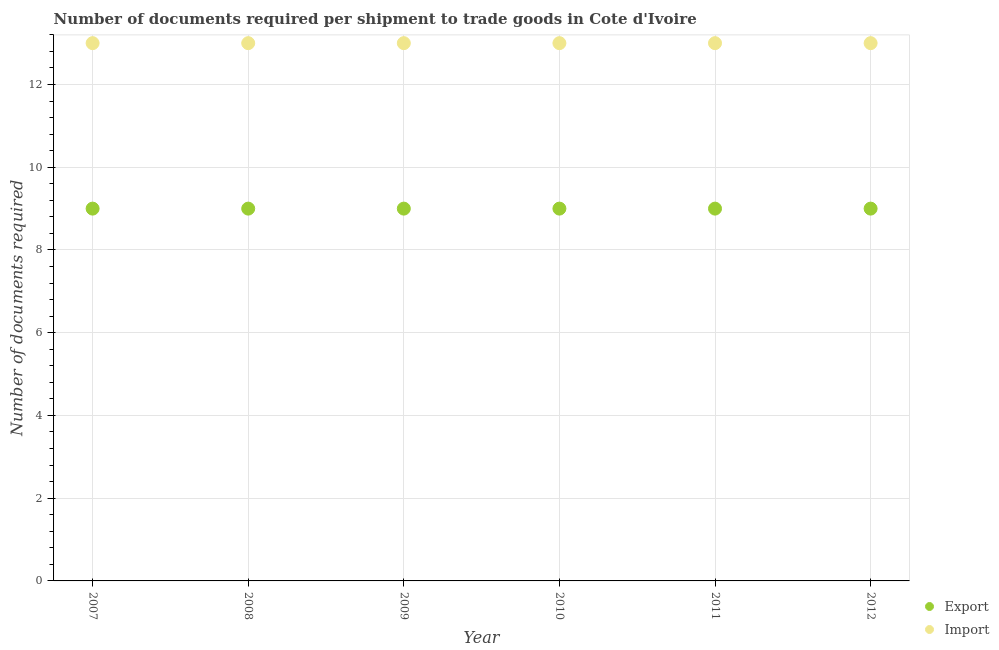What is the number of documents required to export goods in 2012?
Offer a terse response. 9. Across all years, what is the maximum number of documents required to export goods?
Offer a terse response. 9. Across all years, what is the minimum number of documents required to import goods?
Keep it short and to the point. 13. In which year was the number of documents required to import goods minimum?
Your answer should be very brief. 2007. What is the total number of documents required to import goods in the graph?
Offer a very short reply. 78. What is the difference between the number of documents required to import goods in 2011 and the number of documents required to export goods in 2010?
Ensure brevity in your answer.  4. In the year 2011, what is the difference between the number of documents required to export goods and number of documents required to import goods?
Offer a very short reply. -4. What is the ratio of the number of documents required to export goods in 2007 to that in 2008?
Offer a very short reply. 1. What is the difference between the highest and the second highest number of documents required to export goods?
Offer a terse response. 0. Does the number of documents required to export goods monotonically increase over the years?
Offer a very short reply. No. Is the number of documents required to export goods strictly greater than the number of documents required to import goods over the years?
Your answer should be very brief. No. Is the number of documents required to import goods strictly less than the number of documents required to export goods over the years?
Give a very brief answer. No. How many years are there in the graph?
Provide a succinct answer. 6. Does the graph contain grids?
Make the answer very short. Yes. How are the legend labels stacked?
Make the answer very short. Vertical. What is the title of the graph?
Ensure brevity in your answer.  Number of documents required per shipment to trade goods in Cote d'Ivoire. What is the label or title of the X-axis?
Your response must be concise. Year. What is the label or title of the Y-axis?
Your answer should be compact. Number of documents required. What is the Number of documents required of Export in 2008?
Your answer should be very brief. 9. What is the Number of documents required in Export in 2010?
Provide a short and direct response. 9. What is the Number of documents required in Import in 2010?
Ensure brevity in your answer.  13. What is the Number of documents required of Import in 2012?
Your answer should be very brief. 13. Across all years, what is the minimum Number of documents required in Export?
Your answer should be very brief. 9. Across all years, what is the minimum Number of documents required in Import?
Your answer should be compact. 13. What is the total Number of documents required of Export in the graph?
Offer a very short reply. 54. What is the difference between the Number of documents required in Import in 2007 and that in 2010?
Ensure brevity in your answer.  0. What is the difference between the Number of documents required of Export in 2007 and that in 2011?
Provide a succinct answer. 0. What is the difference between the Number of documents required of Import in 2007 and that in 2011?
Give a very brief answer. 0. What is the difference between the Number of documents required in Export in 2007 and that in 2012?
Give a very brief answer. 0. What is the difference between the Number of documents required in Import in 2007 and that in 2012?
Give a very brief answer. 0. What is the difference between the Number of documents required of Export in 2008 and that in 2009?
Offer a terse response. 0. What is the difference between the Number of documents required of Import in 2008 and that in 2009?
Provide a short and direct response. 0. What is the difference between the Number of documents required of Export in 2008 and that in 2010?
Make the answer very short. 0. What is the difference between the Number of documents required of Import in 2008 and that in 2010?
Your response must be concise. 0. What is the difference between the Number of documents required in Export in 2008 and that in 2011?
Give a very brief answer. 0. What is the difference between the Number of documents required in Import in 2008 and that in 2011?
Your answer should be very brief. 0. What is the difference between the Number of documents required of Export in 2008 and that in 2012?
Offer a terse response. 0. What is the difference between the Number of documents required in Import in 2008 and that in 2012?
Your response must be concise. 0. What is the difference between the Number of documents required in Export in 2009 and that in 2010?
Provide a succinct answer. 0. What is the difference between the Number of documents required of Import in 2009 and that in 2011?
Keep it short and to the point. 0. What is the difference between the Number of documents required in Export in 2009 and that in 2012?
Provide a short and direct response. 0. What is the difference between the Number of documents required of Export in 2010 and that in 2011?
Give a very brief answer. 0. What is the difference between the Number of documents required of Export in 2007 and the Number of documents required of Import in 2009?
Your answer should be very brief. -4. What is the difference between the Number of documents required in Export in 2007 and the Number of documents required in Import in 2010?
Ensure brevity in your answer.  -4. What is the difference between the Number of documents required of Export in 2007 and the Number of documents required of Import in 2012?
Your answer should be compact. -4. What is the difference between the Number of documents required of Export in 2008 and the Number of documents required of Import in 2011?
Give a very brief answer. -4. What is the difference between the Number of documents required of Export in 2009 and the Number of documents required of Import in 2012?
Give a very brief answer. -4. What is the difference between the Number of documents required of Export in 2011 and the Number of documents required of Import in 2012?
Your response must be concise. -4. In the year 2007, what is the difference between the Number of documents required of Export and Number of documents required of Import?
Provide a succinct answer. -4. In the year 2009, what is the difference between the Number of documents required in Export and Number of documents required in Import?
Provide a succinct answer. -4. In the year 2010, what is the difference between the Number of documents required in Export and Number of documents required in Import?
Ensure brevity in your answer.  -4. What is the ratio of the Number of documents required in Export in 2007 to that in 2011?
Keep it short and to the point. 1. What is the ratio of the Number of documents required in Import in 2007 to that in 2011?
Your answer should be very brief. 1. What is the ratio of the Number of documents required of Import in 2007 to that in 2012?
Provide a short and direct response. 1. What is the ratio of the Number of documents required in Export in 2008 to that in 2009?
Provide a succinct answer. 1. What is the ratio of the Number of documents required in Import in 2008 to that in 2009?
Give a very brief answer. 1. What is the ratio of the Number of documents required of Export in 2008 to that in 2010?
Ensure brevity in your answer.  1. What is the ratio of the Number of documents required of Import in 2008 to that in 2010?
Keep it short and to the point. 1. What is the ratio of the Number of documents required in Export in 2008 to that in 2011?
Ensure brevity in your answer.  1. What is the ratio of the Number of documents required of Import in 2008 to that in 2011?
Offer a terse response. 1. What is the ratio of the Number of documents required of Import in 2008 to that in 2012?
Offer a terse response. 1. What is the ratio of the Number of documents required of Import in 2009 to that in 2010?
Your response must be concise. 1. What is the ratio of the Number of documents required of Export in 2009 to that in 2011?
Give a very brief answer. 1. What is the ratio of the Number of documents required in Import in 2009 to that in 2011?
Provide a short and direct response. 1. What is the ratio of the Number of documents required of Import in 2009 to that in 2012?
Keep it short and to the point. 1. What is the ratio of the Number of documents required of Export in 2010 to that in 2011?
Give a very brief answer. 1. What is the ratio of the Number of documents required in Export in 2010 to that in 2012?
Your answer should be compact. 1. What is the ratio of the Number of documents required in Export in 2011 to that in 2012?
Give a very brief answer. 1. What is the difference between the highest and the second highest Number of documents required of Export?
Ensure brevity in your answer.  0. 